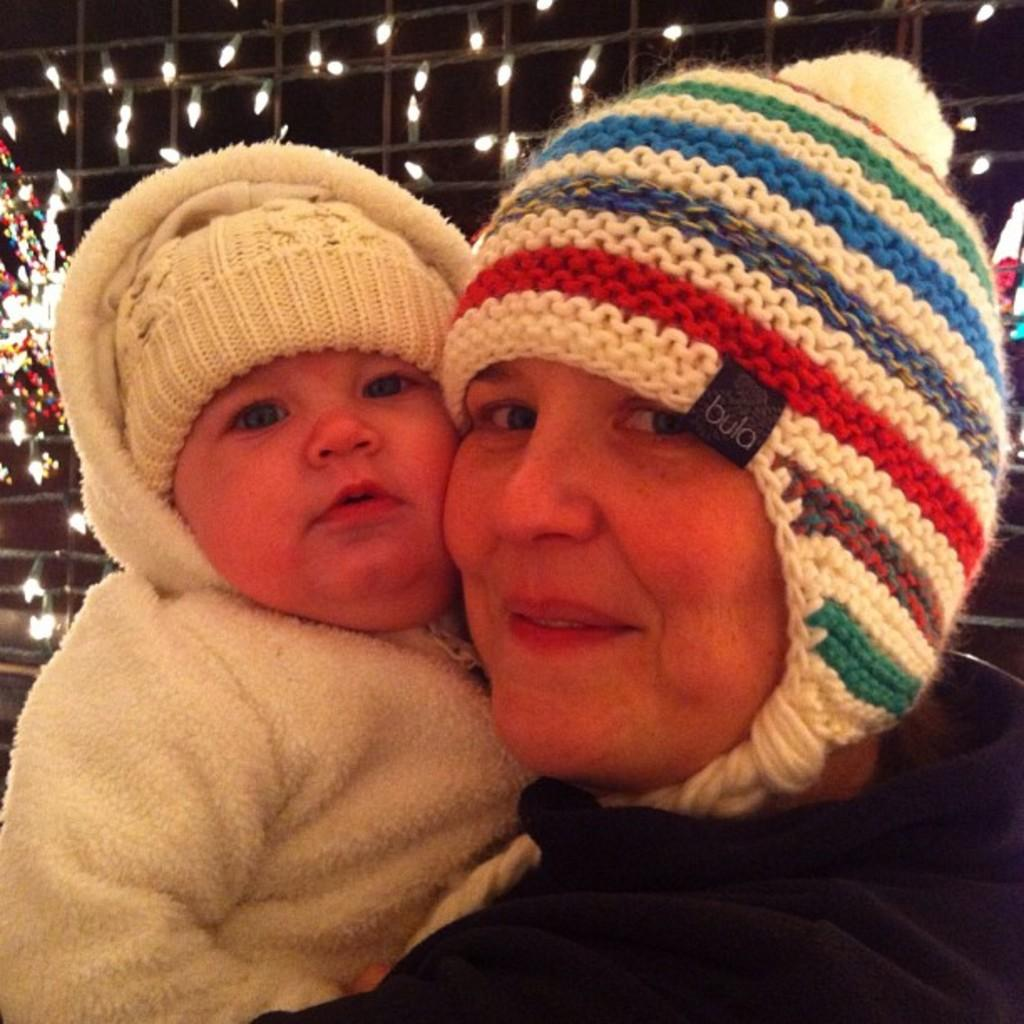Who is present in the image? There is a woman and a child in the image. What are the woman and the child wearing? Both the woman and the child are wearing caps and jackets. What can be seen in the background of the image? There are multiple lights visible in the background of the image. What type of food is the woman feeding the dogs in the image? There are no dogs present in the image, and the woman is not feeding any food to them. 